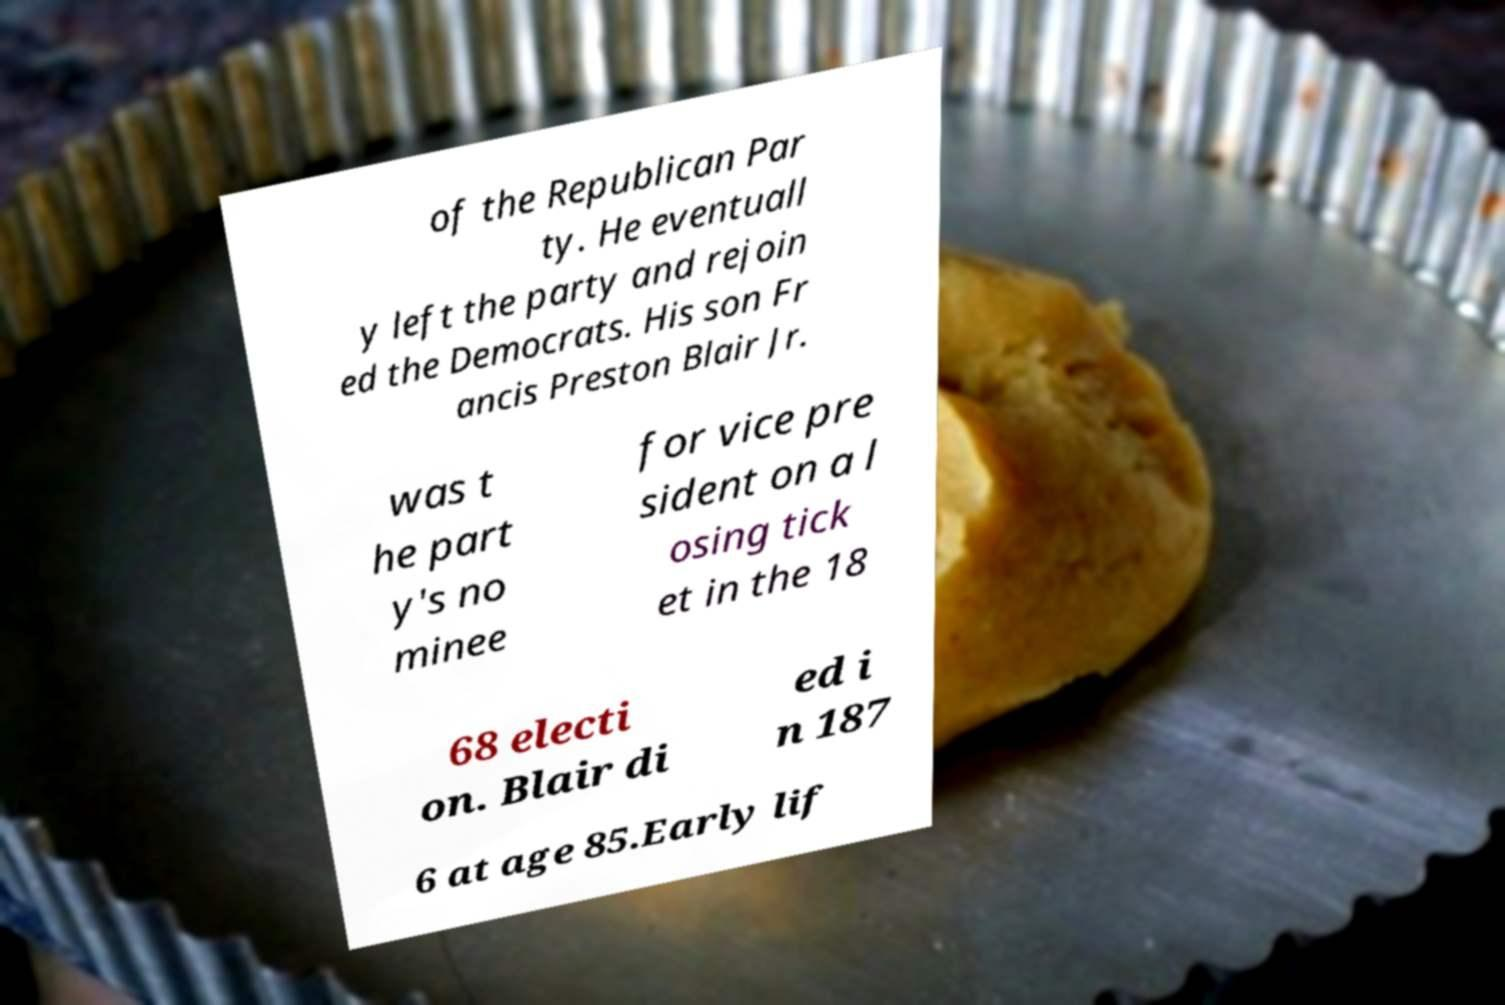What messages or text are displayed in this image? I need them in a readable, typed format. of the Republican Par ty. He eventuall y left the party and rejoin ed the Democrats. His son Fr ancis Preston Blair Jr. was t he part y's no minee for vice pre sident on a l osing tick et in the 18 68 electi on. Blair di ed i n 187 6 at age 85.Early lif 